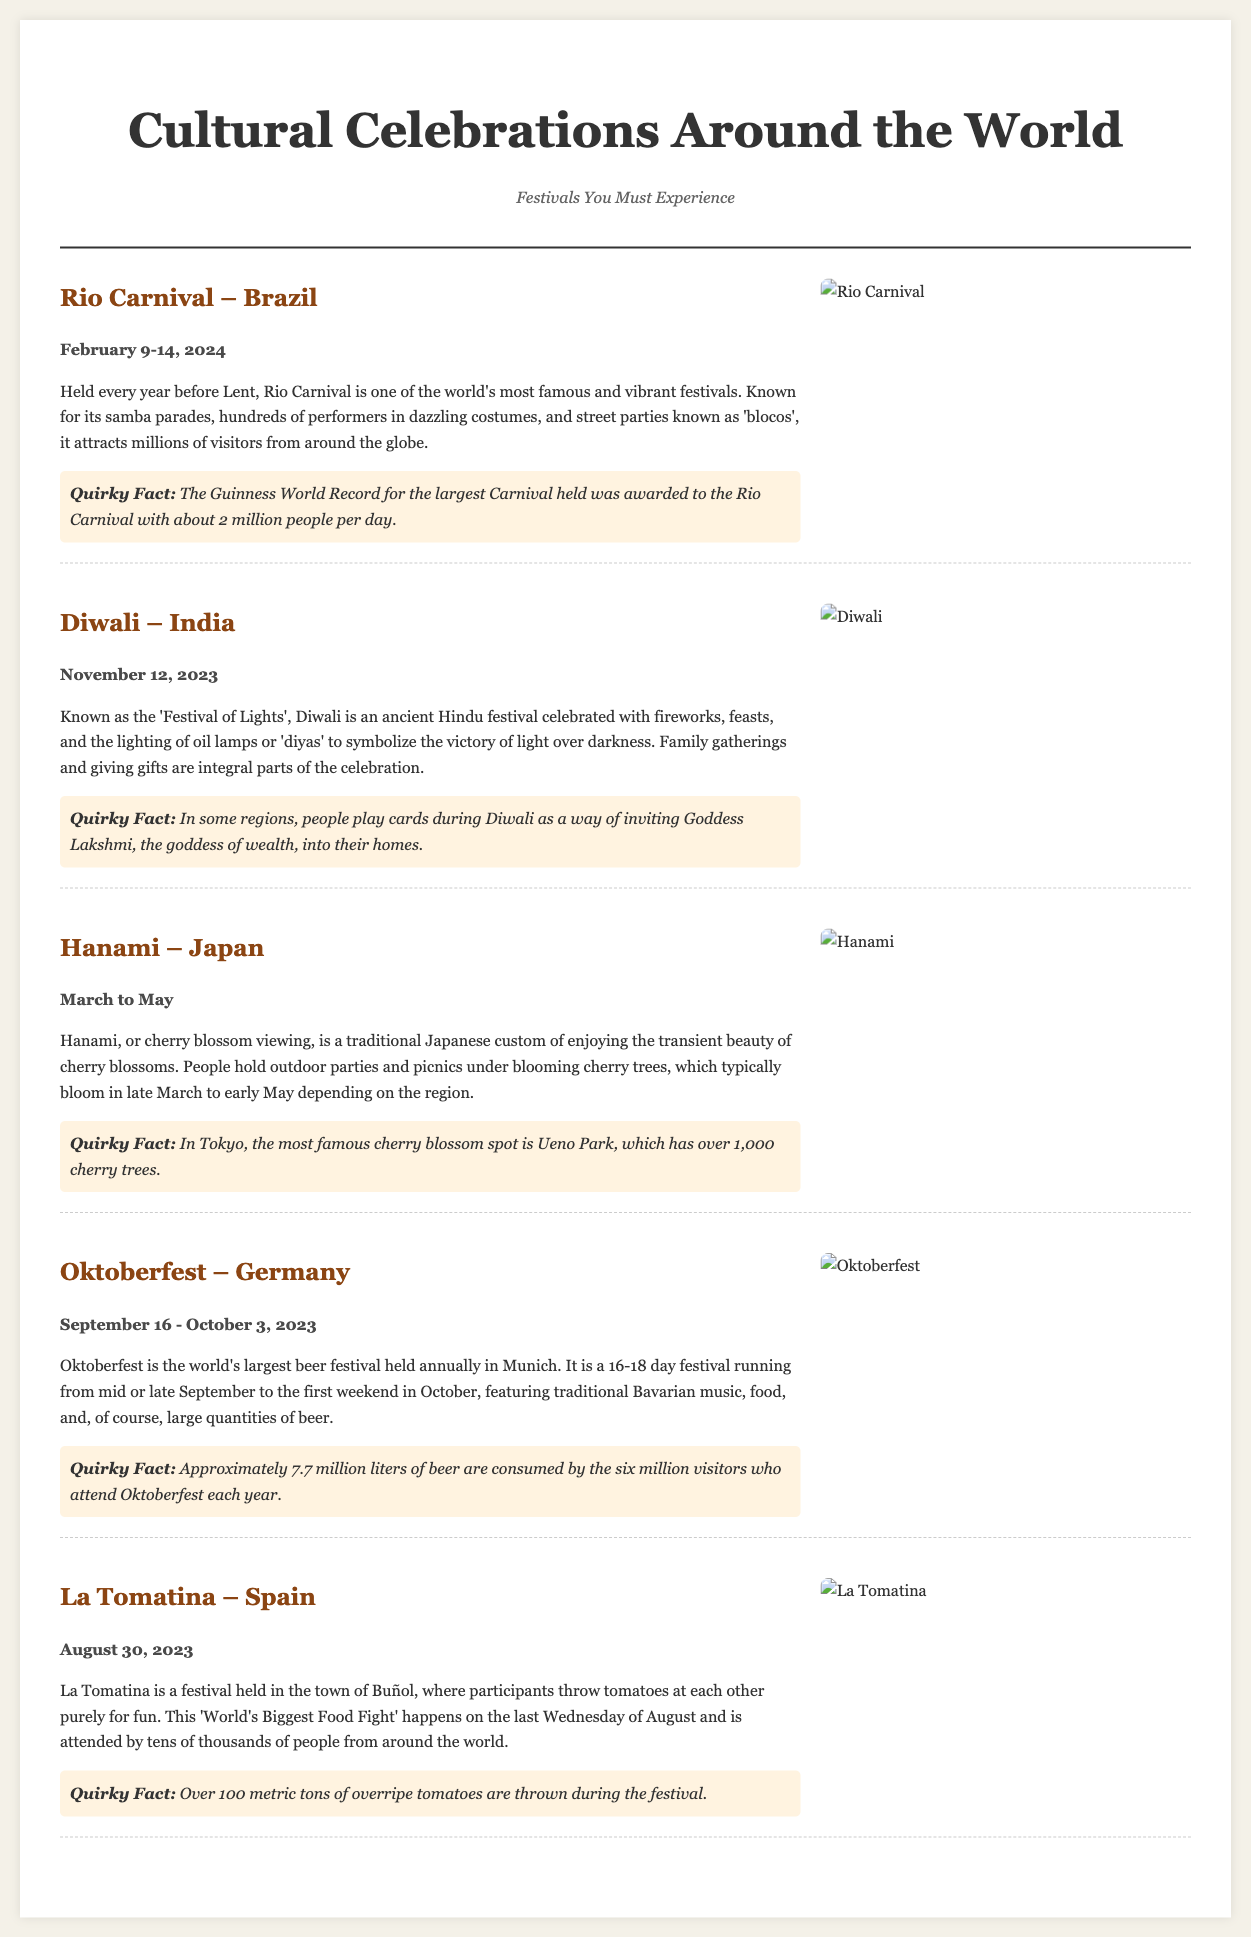What is the date of the Rio Carnival? The date for the Rio Carnival is listed in the document, which is February 9-14, 2024.
Answer: February 9-14, 2024 What festival is known as the 'Festival of Lights'? The document identifies Diwali as the 'Festival of Lights'.
Answer: Diwali How many cherry trees are in Ueno Park? According to the document, Ueno Park has over 1,000 cherry trees.
Answer: Over 1,000 What percentage of total beer consumed at Oktoberfest comes from visitors? The document mentions that approximately 7.7 million liters of beer are consumed by six million visitors, indicating that nearly all beer is consumed by visitors.
Answer: Visitors Which festival involves a large food fight? The document states that La Tomatina is a festival where participants throw tomatoes at each other, making it a food fight event.
Answer: La Tomatina How many months does Hanami span? The document outlines that Hanami occurs from March to May, indicating it spans three months.
Answer: Three months What quirky fact is mentioned about Diwali? The document provides a quirky fact regarding card playing during Diwali as an invitation to Goddess Lakshmi.
Answer: Playing cards during Diwali What is the duration of Oktoberfest? The document specifies the duration of Oktoberfest as 16-18 days.
Answer: 16-18 days 